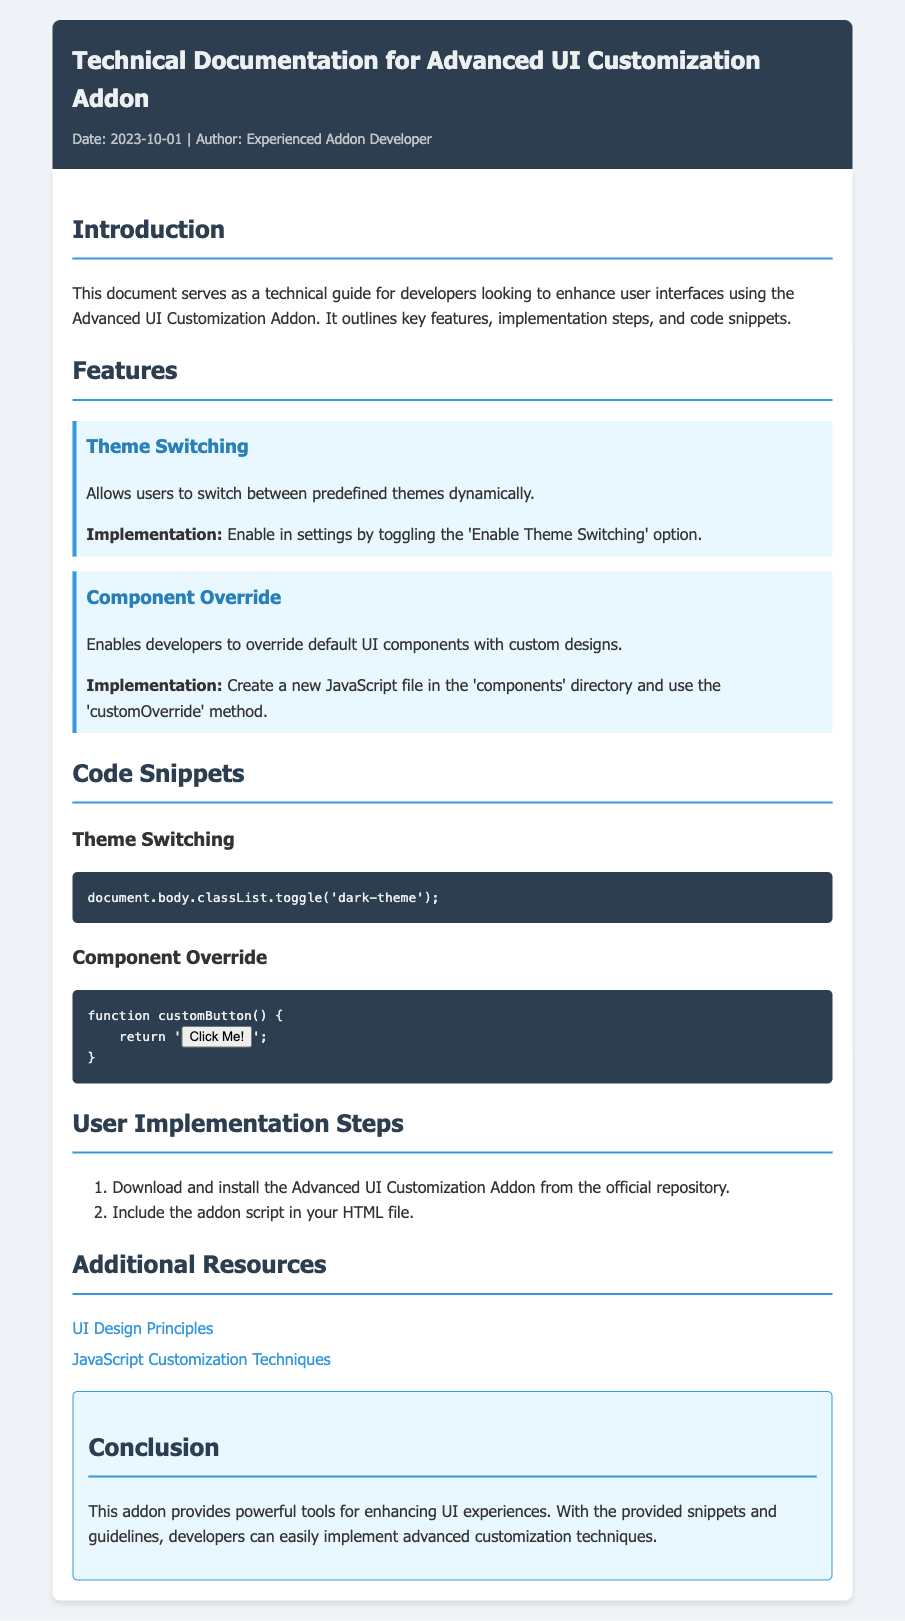What is the date of the document? The date of the document is presented in the metadata section at the top of the document.
Answer: 2023-10-01 Who is the author of the document? The author is also mentioned in the metadata section alongside the date.
Answer: Experienced Addon Developer What feature allows users to switch between themes? The feature that allows theme switching is specified in the "Features" section.
Answer: Theme Switching What is the function name provided for overriding UI components? The function name for component override is mentioned in the "Code Snippets" section.
Answer: customButton How many user implementation steps are provided? The number of implementation steps can be counted in the "User Implementation Steps" section.
Answer: 2 What color is used for the document's header background? The color used for the header's background is specified in the style rules of the document.
Answer: Dark blue What URL leads to UI Design Principles? The resource section lists additional links, including this specific one for UI Design Principles.
Answer: https://www.uidesignprinciples.com What methods are discussed for enhancing user interfaces? The methods to enhance interfaces are outlined based on the features of the addon discussed in the memo.
Answer: Theme Switching, Component Override 